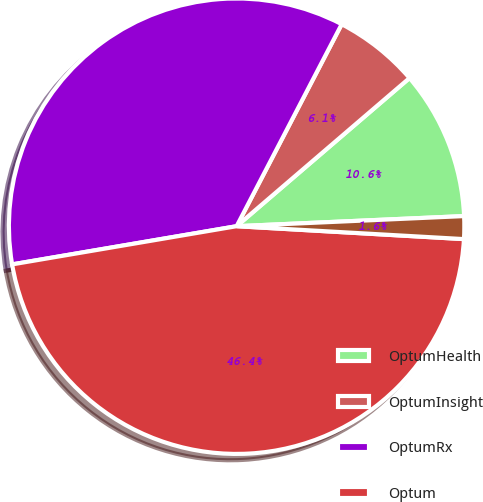<chart> <loc_0><loc_0><loc_500><loc_500><pie_chart><fcel>OptumHealth<fcel>OptumInsight<fcel>OptumRx<fcel>Optum<fcel>UnitedHealthcare<nl><fcel>10.57%<fcel>6.09%<fcel>35.32%<fcel>46.42%<fcel>1.61%<nl></chart> 